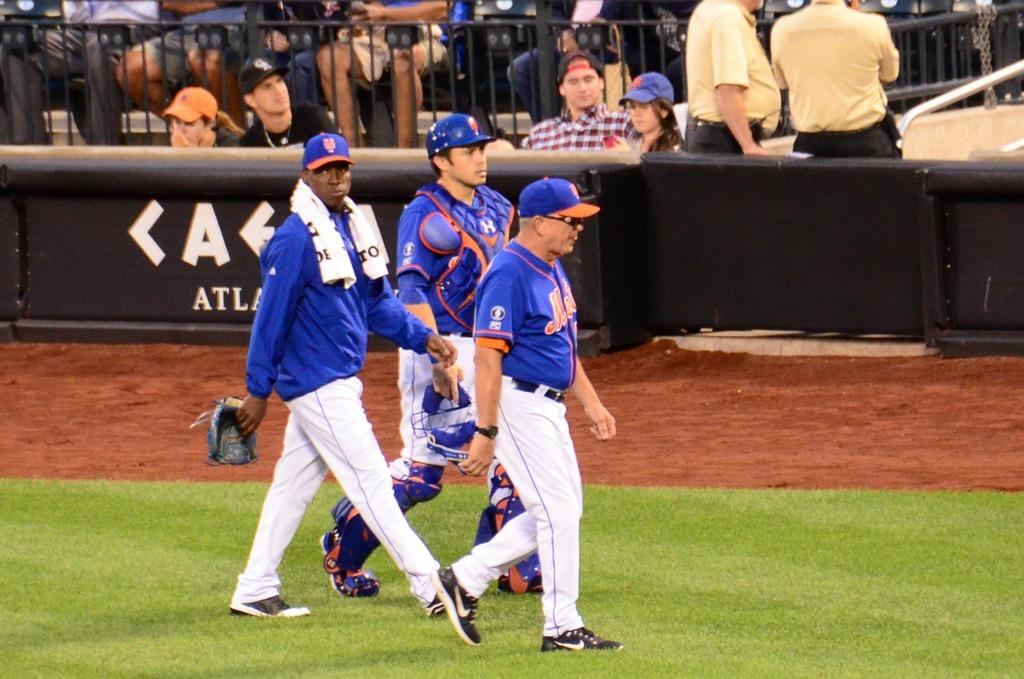<image>
Write a terse but informative summary of the picture. Mets players and personnel make their way across the baseball field. 